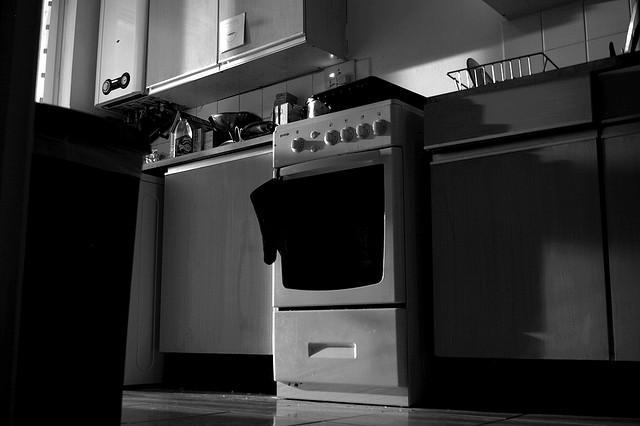What goes in the drawer under the stove?
Concise answer only. Pans. What room is shown?
Keep it brief. Kitchen. Are there any dishes in the drying rack?
Give a very brief answer. Yes. What room is pictured?
Answer briefly. Kitchen. Is this a good picture?
Concise answer only. Yes. 